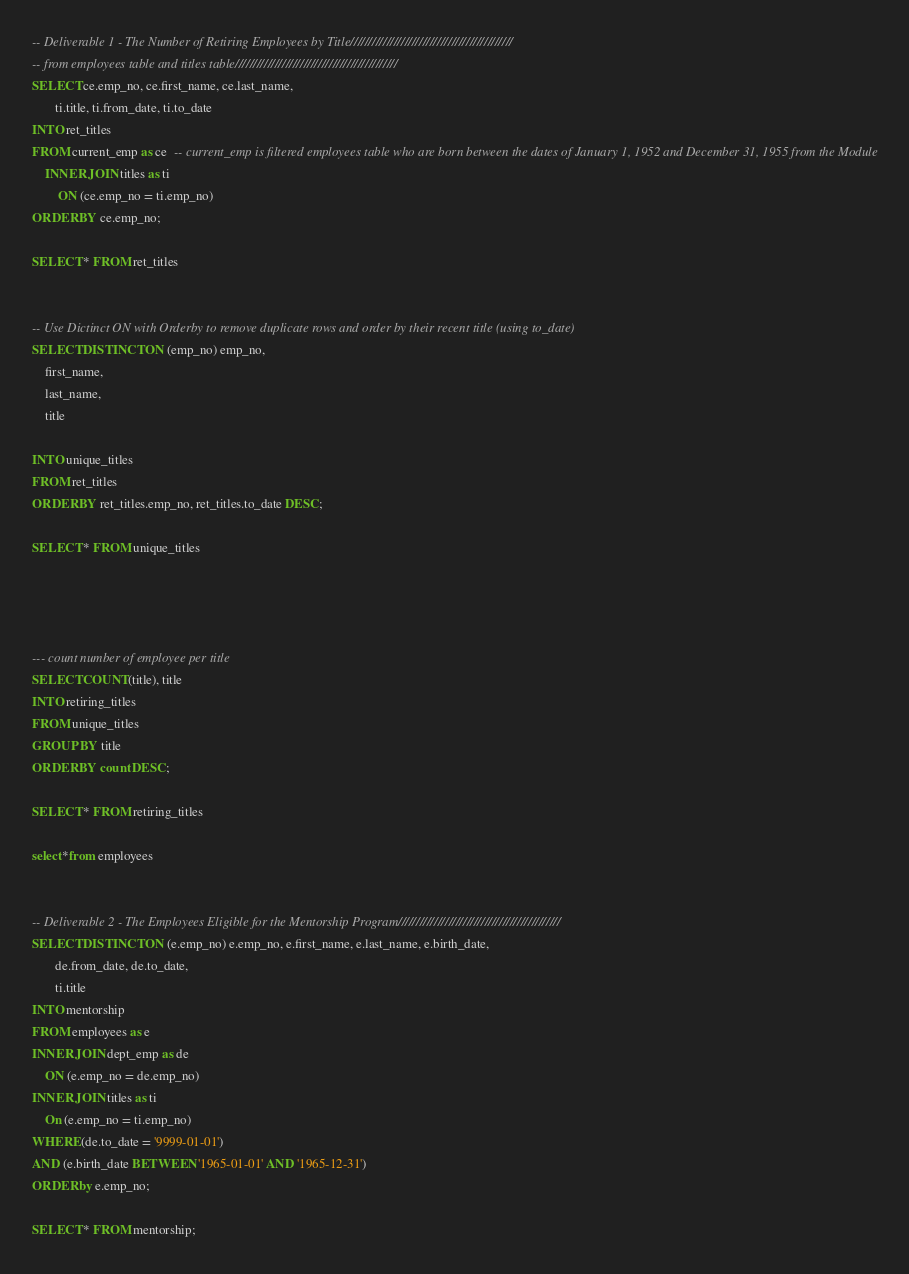<code> <loc_0><loc_0><loc_500><loc_500><_SQL_>-- Deliverable 1 - The Number of Retiring Employees by Title/////////////////////////////////////////////
-- from employees table and titles table/////////////////////////////////////////////
SELECT ce.emp_no, ce.first_name, ce.last_name,
	   ti.title, ti.from_date, ti.to_date
INTO ret_titles
FROM current_emp as ce  -- current_emp is filtered employees table who are born between the dates of January 1, 1952 and December 31, 1955 from the Module
	INNER JOIN titles as ti
		ON (ce.emp_no = ti.emp_no)
ORDER BY ce.emp_no;

SELECT * FROM ret_titles


-- Use Dictinct ON with Orderby to remove duplicate rows and order by their recent title (using to_date)
SELECT DISTINCT ON (emp_no) emp_no,
	first_name,
	last_name,
	title

INTO unique_titles
FROM ret_titles
ORDER BY ret_titles.emp_no, ret_titles.to_date DESC;

SELECT * FROM unique_titles




--- count number of employee per title
SELECT COUNT(title), title
INTO retiring_titles
FROM unique_titles
GROUP BY title
ORDER BY count DESC;

SELECT * FROM retiring_titles

select*from employees


-- Deliverable 2 - The Employees Eligible for the Mentorship Program/////////////////////////////////////////////
SELECT DISTINCT ON (e.emp_no) e.emp_no, e.first_name, e.last_name, e.birth_date,
	   de.from_date, de.to_date,
	   ti.title
INTO mentorship
FROM employees as e
INNER JOIN dept_emp as de
	ON (e.emp_no = de.emp_no)
INNER JOIN titles as ti
	On (e.emp_no = ti.emp_no)
WHERE (de.to_date = '9999-01-01')
AND (e.birth_date BETWEEN '1965-01-01' AND '1965-12-31')
ORDER by e.emp_no;

SELECT * FROM mentorship;
</code> 